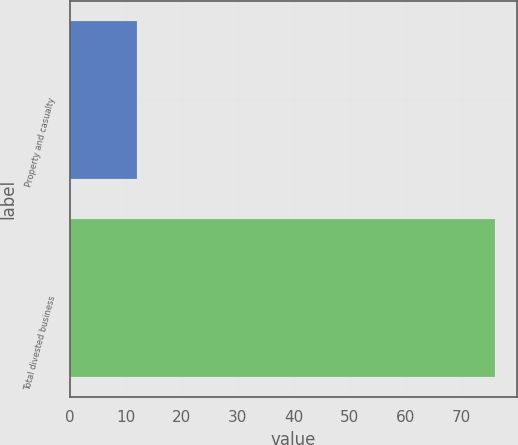Convert chart to OTSL. <chart><loc_0><loc_0><loc_500><loc_500><bar_chart><fcel>Property and casualty<fcel>Total divested business<nl><fcel>12<fcel>76<nl></chart> 